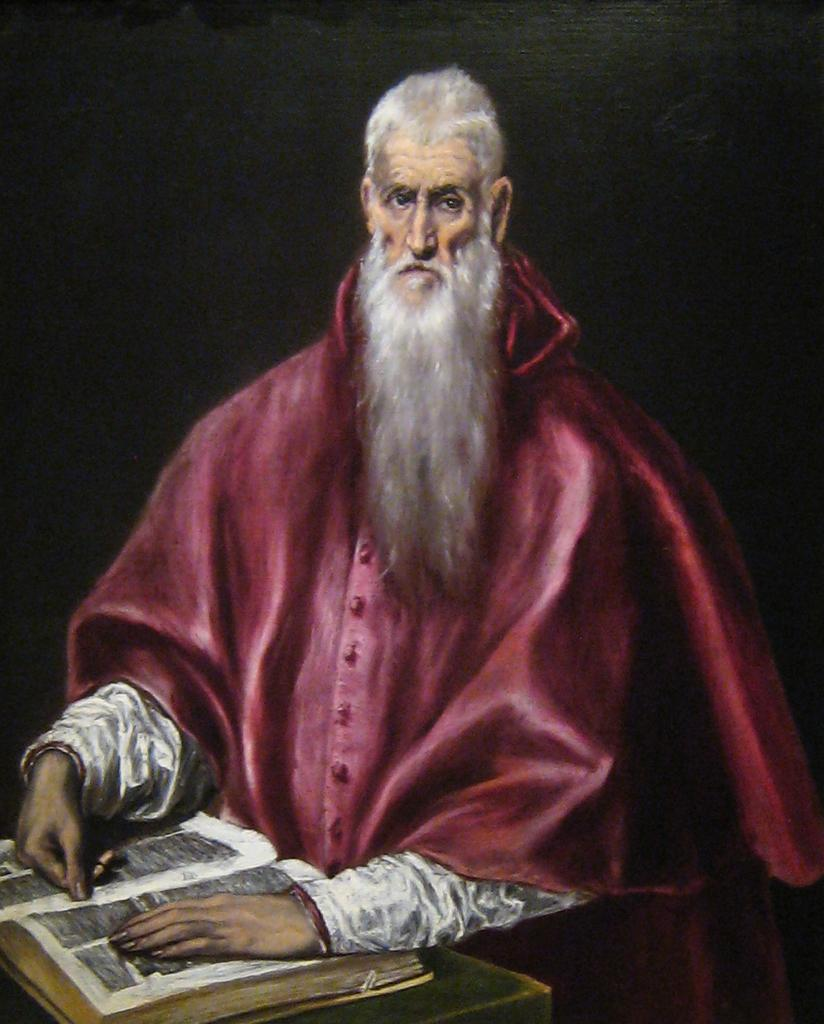Who is present in the image? There is a man in the image. What is the man doing in the image? The man has his hands on a book in the image. Where is the book located? The book is on a table in the image. What can be observed about the background of the image? The background of the image is dark. What types of toys are scattered around the man in the image? There are no toys present in the image; it only features a man with his hands on a book. What kind of pies can be seen on the table next to the book? There are no pies present in the image; the only item on the table is the book. 